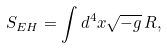<formula> <loc_0><loc_0><loc_500><loc_500>S _ { E H } = \int d ^ { 4 } x \sqrt { - g } \, R ,</formula> 